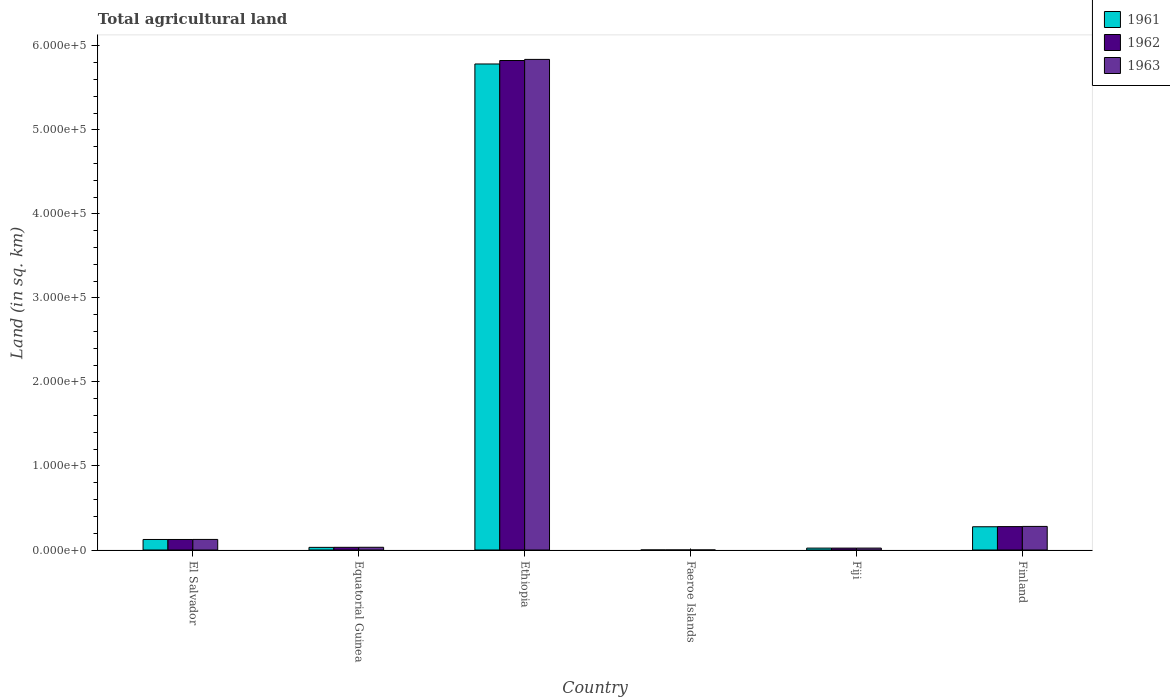How many different coloured bars are there?
Provide a succinct answer. 3. What is the label of the 5th group of bars from the left?
Give a very brief answer. Fiji. In how many cases, is the number of bars for a given country not equal to the number of legend labels?
Give a very brief answer. 0. What is the total agricultural land in 1962 in El Salvador?
Your answer should be compact. 1.25e+04. Across all countries, what is the maximum total agricultural land in 1962?
Your response must be concise. 5.82e+05. Across all countries, what is the minimum total agricultural land in 1961?
Your answer should be very brief. 30. In which country was the total agricultural land in 1963 maximum?
Keep it short and to the point. Ethiopia. In which country was the total agricultural land in 1962 minimum?
Offer a very short reply. Faeroe Islands. What is the total total agricultural land in 1962 in the graph?
Keep it short and to the point. 6.28e+05. What is the difference between the total agricultural land in 1962 in Faeroe Islands and that in Finland?
Your answer should be very brief. -2.78e+04. What is the difference between the total agricultural land in 1961 in Ethiopia and the total agricultural land in 1963 in Fiji?
Provide a succinct answer. 5.76e+05. What is the average total agricultural land in 1961 per country?
Ensure brevity in your answer.  1.04e+05. What is the difference between the total agricultural land of/in 1961 and total agricultural land of/in 1962 in Faeroe Islands?
Provide a succinct answer. 0. What is the ratio of the total agricultural land in 1963 in Faeroe Islands to that in Finland?
Your answer should be compact. 0. Is the total agricultural land in 1963 in Equatorial Guinea less than that in Fiji?
Offer a terse response. No. What is the difference between the highest and the second highest total agricultural land in 1962?
Your answer should be very brief. -5.70e+05. What is the difference between the highest and the lowest total agricultural land in 1963?
Your response must be concise. 5.84e+05. Is the sum of the total agricultural land in 1963 in Ethiopia and Fiji greater than the maximum total agricultural land in 1961 across all countries?
Make the answer very short. Yes. What does the 2nd bar from the left in Finland represents?
Give a very brief answer. 1962. What does the 2nd bar from the right in Finland represents?
Provide a succinct answer. 1962. How many countries are there in the graph?
Your answer should be very brief. 6. Does the graph contain grids?
Your answer should be very brief. No. Where does the legend appear in the graph?
Ensure brevity in your answer.  Top right. How are the legend labels stacked?
Make the answer very short. Vertical. What is the title of the graph?
Your answer should be very brief. Total agricultural land. Does "1972" appear as one of the legend labels in the graph?
Give a very brief answer. No. What is the label or title of the X-axis?
Offer a very short reply. Country. What is the label or title of the Y-axis?
Provide a succinct answer. Land (in sq. km). What is the Land (in sq. km) of 1961 in El Salvador?
Your answer should be very brief. 1.25e+04. What is the Land (in sq. km) of 1962 in El Salvador?
Ensure brevity in your answer.  1.25e+04. What is the Land (in sq. km) in 1963 in El Salvador?
Offer a very short reply. 1.26e+04. What is the Land (in sq. km) in 1961 in Equatorial Guinea?
Ensure brevity in your answer.  3140. What is the Land (in sq. km) in 1962 in Equatorial Guinea?
Your answer should be very brief. 3190. What is the Land (in sq. km) in 1963 in Equatorial Guinea?
Your answer should be very brief. 3240. What is the Land (in sq. km) of 1961 in Ethiopia?
Provide a succinct answer. 5.78e+05. What is the Land (in sq. km) in 1962 in Ethiopia?
Provide a succinct answer. 5.82e+05. What is the Land (in sq. km) in 1963 in Ethiopia?
Your answer should be very brief. 5.84e+05. What is the Land (in sq. km) in 1961 in Faeroe Islands?
Your answer should be compact. 30. What is the Land (in sq. km) of 1962 in Faeroe Islands?
Give a very brief answer. 30. What is the Land (in sq. km) in 1961 in Fiji?
Provide a succinct answer. 2270. What is the Land (in sq. km) in 1962 in Fiji?
Provide a short and direct response. 2270. What is the Land (in sq. km) of 1963 in Fiji?
Provide a short and direct response. 2280. What is the Land (in sq. km) in 1961 in Finland?
Give a very brief answer. 2.77e+04. What is the Land (in sq. km) of 1962 in Finland?
Your response must be concise. 2.79e+04. What is the Land (in sq. km) in 1963 in Finland?
Ensure brevity in your answer.  2.81e+04. Across all countries, what is the maximum Land (in sq. km) in 1961?
Provide a succinct answer. 5.78e+05. Across all countries, what is the maximum Land (in sq. km) in 1962?
Provide a succinct answer. 5.82e+05. Across all countries, what is the maximum Land (in sq. km) in 1963?
Provide a succinct answer. 5.84e+05. Across all countries, what is the minimum Land (in sq. km) in 1962?
Make the answer very short. 30. What is the total Land (in sq. km) in 1961 in the graph?
Ensure brevity in your answer.  6.24e+05. What is the total Land (in sq. km) of 1962 in the graph?
Provide a succinct answer. 6.28e+05. What is the total Land (in sq. km) in 1963 in the graph?
Your answer should be compact. 6.30e+05. What is the difference between the Land (in sq. km) of 1961 in El Salvador and that in Equatorial Guinea?
Provide a short and direct response. 9380. What is the difference between the Land (in sq. km) of 1962 in El Salvador and that in Equatorial Guinea?
Make the answer very short. 9330. What is the difference between the Land (in sq. km) in 1963 in El Salvador and that in Equatorial Guinea?
Provide a succinct answer. 9340. What is the difference between the Land (in sq. km) of 1961 in El Salvador and that in Ethiopia?
Your response must be concise. -5.66e+05. What is the difference between the Land (in sq. km) in 1962 in El Salvador and that in Ethiopia?
Ensure brevity in your answer.  -5.70e+05. What is the difference between the Land (in sq. km) of 1963 in El Salvador and that in Ethiopia?
Provide a short and direct response. -5.71e+05. What is the difference between the Land (in sq. km) in 1961 in El Salvador and that in Faeroe Islands?
Provide a short and direct response. 1.25e+04. What is the difference between the Land (in sq. km) of 1962 in El Salvador and that in Faeroe Islands?
Your answer should be very brief. 1.25e+04. What is the difference between the Land (in sq. km) in 1963 in El Salvador and that in Faeroe Islands?
Provide a succinct answer. 1.26e+04. What is the difference between the Land (in sq. km) of 1961 in El Salvador and that in Fiji?
Give a very brief answer. 1.02e+04. What is the difference between the Land (in sq. km) in 1962 in El Salvador and that in Fiji?
Offer a very short reply. 1.02e+04. What is the difference between the Land (in sq. km) of 1963 in El Salvador and that in Fiji?
Your answer should be very brief. 1.03e+04. What is the difference between the Land (in sq. km) in 1961 in El Salvador and that in Finland?
Ensure brevity in your answer.  -1.51e+04. What is the difference between the Land (in sq. km) in 1962 in El Salvador and that in Finland?
Offer a terse response. -1.53e+04. What is the difference between the Land (in sq. km) of 1963 in El Salvador and that in Finland?
Your answer should be very brief. -1.55e+04. What is the difference between the Land (in sq. km) in 1961 in Equatorial Guinea and that in Ethiopia?
Your response must be concise. -5.75e+05. What is the difference between the Land (in sq. km) of 1962 in Equatorial Guinea and that in Ethiopia?
Ensure brevity in your answer.  -5.79e+05. What is the difference between the Land (in sq. km) in 1963 in Equatorial Guinea and that in Ethiopia?
Offer a terse response. -5.81e+05. What is the difference between the Land (in sq. km) of 1961 in Equatorial Guinea and that in Faeroe Islands?
Keep it short and to the point. 3110. What is the difference between the Land (in sq. km) in 1962 in Equatorial Guinea and that in Faeroe Islands?
Provide a short and direct response. 3160. What is the difference between the Land (in sq. km) in 1963 in Equatorial Guinea and that in Faeroe Islands?
Give a very brief answer. 3210. What is the difference between the Land (in sq. km) in 1961 in Equatorial Guinea and that in Fiji?
Provide a short and direct response. 870. What is the difference between the Land (in sq. km) of 1962 in Equatorial Guinea and that in Fiji?
Provide a short and direct response. 920. What is the difference between the Land (in sq. km) of 1963 in Equatorial Guinea and that in Fiji?
Provide a short and direct response. 960. What is the difference between the Land (in sq. km) of 1961 in Equatorial Guinea and that in Finland?
Your answer should be very brief. -2.45e+04. What is the difference between the Land (in sq. km) of 1962 in Equatorial Guinea and that in Finland?
Your answer should be very brief. -2.47e+04. What is the difference between the Land (in sq. km) of 1963 in Equatorial Guinea and that in Finland?
Ensure brevity in your answer.  -2.48e+04. What is the difference between the Land (in sq. km) in 1961 in Ethiopia and that in Faeroe Islands?
Make the answer very short. 5.78e+05. What is the difference between the Land (in sq. km) of 1962 in Ethiopia and that in Faeroe Islands?
Your response must be concise. 5.82e+05. What is the difference between the Land (in sq. km) of 1963 in Ethiopia and that in Faeroe Islands?
Offer a very short reply. 5.84e+05. What is the difference between the Land (in sq. km) in 1961 in Ethiopia and that in Fiji?
Keep it short and to the point. 5.76e+05. What is the difference between the Land (in sq. km) of 1962 in Ethiopia and that in Fiji?
Give a very brief answer. 5.80e+05. What is the difference between the Land (in sq. km) of 1963 in Ethiopia and that in Fiji?
Offer a terse response. 5.82e+05. What is the difference between the Land (in sq. km) of 1961 in Ethiopia and that in Finland?
Your answer should be compact. 5.51e+05. What is the difference between the Land (in sq. km) of 1962 in Ethiopia and that in Finland?
Provide a short and direct response. 5.55e+05. What is the difference between the Land (in sq. km) of 1963 in Ethiopia and that in Finland?
Give a very brief answer. 5.56e+05. What is the difference between the Land (in sq. km) of 1961 in Faeroe Islands and that in Fiji?
Your response must be concise. -2240. What is the difference between the Land (in sq. km) in 1962 in Faeroe Islands and that in Fiji?
Provide a short and direct response. -2240. What is the difference between the Land (in sq. km) of 1963 in Faeroe Islands and that in Fiji?
Provide a short and direct response. -2250. What is the difference between the Land (in sq. km) in 1961 in Faeroe Islands and that in Finland?
Ensure brevity in your answer.  -2.76e+04. What is the difference between the Land (in sq. km) in 1962 in Faeroe Islands and that in Finland?
Your answer should be compact. -2.78e+04. What is the difference between the Land (in sq. km) of 1963 in Faeroe Islands and that in Finland?
Keep it short and to the point. -2.80e+04. What is the difference between the Land (in sq. km) of 1961 in Fiji and that in Finland?
Keep it short and to the point. -2.54e+04. What is the difference between the Land (in sq. km) of 1962 in Fiji and that in Finland?
Your answer should be compact. -2.56e+04. What is the difference between the Land (in sq. km) in 1963 in Fiji and that in Finland?
Your answer should be very brief. -2.58e+04. What is the difference between the Land (in sq. km) in 1961 in El Salvador and the Land (in sq. km) in 1962 in Equatorial Guinea?
Your answer should be compact. 9330. What is the difference between the Land (in sq. km) in 1961 in El Salvador and the Land (in sq. km) in 1963 in Equatorial Guinea?
Your answer should be compact. 9280. What is the difference between the Land (in sq. km) of 1962 in El Salvador and the Land (in sq. km) of 1963 in Equatorial Guinea?
Your answer should be very brief. 9280. What is the difference between the Land (in sq. km) in 1961 in El Salvador and the Land (in sq. km) in 1962 in Ethiopia?
Your answer should be compact. -5.70e+05. What is the difference between the Land (in sq. km) in 1961 in El Salvador and the Land (in sq. km) in 1963 in Ethiopia?
Make the answer very short. -5.71e+05. What is the difference between the Land (in sq. km) in 1962 in El Salvador and the Land (in sq. km) in 1963 in Ethiopia?
Keep it short and to the point. -5.71e+05. What is the difference between the Land (in sq. km) of 1961 in El Salvador and the Land (in sq. km) of 1962 in Faeroe Islands?
Provide a short and direct response. 1.25e+04. What is the difference between the Land (in sq. km) of 1961 in El Salvador and the Land (in sq. km) of 1963 in Faeroe Islands?
Your answer should be very brief. 1.25e+04. What is the difference between the Land (in sq. km) in 1962 in El Salvador and the Land (in sq. km) in 1963 in Faeroe Islands?
Provide a succinct answer. 1.25e+04. What is the difference between the Land (in sq. km) in 1961 in El Salvador and the Land (in sq. km) in 1962 in Fiji?
Make the answer very short. 1.02e+04. What is the difference between the Land (in sq. km) in 1961 in El Salvador and the Land (in sq. km) in 1963 in Fiji?
Your response must be concise. 1.02e+04. What is the difference between the Land (in sq. km) in 1962 in El Salvador and the Land (in sq. km) in 1963 in Fiji?
Give a very brief answer. 1.02e+04. What is the difference between the Land (in sq. km) of 1961 in El Salvador and the Land (in sq. km) of 1962 in Finland?
Provide a succinct answer. -1.53e+04. What is the difference between the Land (in sq. km) in 1961 in El Salvador and the Land (in sq. km) in 1963 in Finland?
Offer a very short reply. -1.55e+04. What is the difference between the Land (in sq. km) of 1962 in El Salvador and the Land (in sq. km) of 1963 in Finland?
Your answer should be very brief. -1.55e+04. What is the difference between the Land (in sq. km) of 1961 in Equatorial Guinea and the Land (in sq. km) of 1962 in Ethiopia?
Your response must be concise. -5.79e+05. What is the difference between the Land (in sq. km) of 1961 in Equatorial Guinea and the Land (in sq. km) of 1963 in Ethiopia?
Your answer should be compact. -5.81e+05. What is the difference between the Land (in sq. km) in 1962 in Equatorial Guinea and the Land (in sq. km) in 1963 in Ethiopia?
Provide a short and direct response. -5.81e+05. What is the difference between the Land (in sq. km) of 1961 in Equatorial Guinea and the Land (in sq. km) of 1962 in Faeroe Islands?
Your answer should be very brief. 3110. What is the difference between the Land (in sq. km) in 1961 in Equatorial Guinea and the Land (in sq. km) in 1963 in Faeroe Islands?
Ensure brevity in your answer.  3110. What is the difference between the Land (in sq. km) in 1962 in Equatorial Guinea and the Land (in sq. km) in 1963 in Faeroe Islands?
Offer a very short reply. 3160. What is the difference between the Land (in sq. km) in 1961 in Equatorial Guinea and the Land (in sq. km) in 1962 in Fiji?
Your answer should be very brief. 870. What is the difference between the Land (in sq. km) in 1961 in Equatorial Guinea and the Land (in sq. km) in 1963 in Fiji?
Give a very brief answer. 860. What is the difference between the Land (in sq. km) in 1962 in Equatorial Guinea and the Land (in sq. km) in 1963 in Fiji?
Your response must be concise. 910. What is the difference between the Land (in sq. km) in 1961 in Equatorial Guinea and the Land (in sq. km) in 1962 in Finland?
Offer a terse response. -2.47e+04. What is the difference between the Land (in sq. km) in 1961 in Equatorial Guinea and the Land (in sq. km) in 1963 in Finland?
Keep it short and to the point. -2.49e+04. What is the difference between the Land (in sq. km) of 1962 in Equatorial Guinea and the Land (in sq. km) of 1963 in Finland?
Provide a succinct answer. -2.49e+04. What is the difference between the Land (in sq. km) of 1961 in Ethiopia and the Land (in sq. km) of 1962 in Faeroe Islands?
Make the answer very short. 5.78e+05. What is the difference between the Land (in sq. km) of 1961 in Ethiopia and the Land (in sq. km) of 1963 in Faeroe Islands?
Provide a succinct answer. 5.78e+05. What is the difference between the Land (in sq. km) in 1962 in Ethiopia and the Land (in sq. km) in 1963 in Faeroe Islands?
Make the answer very short. 5.82e+05. What is the difference between the Land (in sq. km) in 1961 in Ethiopia and the Land (in sq. km) in 1962 in Fiji?
Your answer should be compact. 5.76e+05. What is the difference between the Land (in sq. km) in 1961 in Ethiopia and the Land (in sq. km) in 1963 in Fiji?
Give a very brief answer. 5.76e+05. What is the difference between the Land (in sq. km) of 1962 in Ethiopia and the Land (in sq. km) of 1963 in Fiji?
Your answer should be compact. 5.80e+05. What is the difference between the Land (in sq. km) in 1961 in Ethiopia and the Land (in sq. km) in 1962 in Finland?
Your response must be concise. 5.51e+05. What is the difference between the Land (in sq. km) of 1961 in Ethiopia and the Land (in sq. km) of 1963 in Finland?
Make the answer very short. 5.50e+05. What is the difference between the Land (in sq. km) in 1962 in Ethiopia and the Land (in sq. km) in 1963 in Finland?
Give a very brief answer. 5.54e+05. What is the difference between the Land (in sq. km) of 1961 in Faeroe Islands and the Land (in sq. km) of 1962 in Fiji?
Offer a terse response. -2240. What is the difference between the Land (in sq. km) of 1961 in Faeroe Islands and the Land (in sq. km) of 1963 in Fiji?
Give a very brief answer. -2250. What is the difference between the Land (in sq. km) in 1962 in Faeroe Islands and the Land (in sq. km) in 1963 in Fiji?
Provide a succinct answer. -2250. What is the difference between the Land (in sq. km) in 1961 in Faeroe Islands and the Land (in sq. km) in 1962 in Finland?
Provide a short and direct response. -2.78e+04. What is the difference between the Land (in sq. km) in 1961 in Faeroe Islands and the Land (in sq. km) in 1963 in Finland?
Offer a very short reply. -2.80e+04. What is the difference between the Land (in sq. km) of 1962 in Faeroe Islands and the Land (in sq. km) of 1963 in Finland?
Ensure brevity in your answer.  -2.80e+04. What is the difference between the Land (in sq. km) of 1961 in Fiji and the Land (in sq. km) of 1962 in Finland?
Offer a very short reply. -2.56e+04. What is the difference between the Land (in sq. km) of 1961 in Fiji and the Land (in sq. km) of 1963 in Finland?
Keep it short and to the point. -2.58e+04. What is the difference between the Land (in sq. km) of 1962 in Fiji and the Land (in sq. km) of 1963 in Finland?
Give a very brief answer. -2.58e+04. What is the average Land (in sq. km) of 1961 per country?
Keep it short and to the point. 1.04e+05. What is the average Land (in sq. km) in 1962 per country?
Make the answer very short. 1.05e+05. What is the average Land (in sq. km) in 1963 per country?
Keep it short and to the point. 1.05e+05. What is the difference between the Land (in sq. km) of 1961 and Land (in sq. km) of 1962 in El Salvador?
Offer a very short reply. 0. What is the difference between the Land (in sq. km) of 1961 and Land (in sq. km) of 1963 in El Salvador?
Keep it short and to the point. -60. What is the difference between the Land (in sq. km) of 1962 and Land (in sq. km) of 1963 in El Salvador?
Offer a terse response. -60. What is the difference between the Land (in sq. km) in 1961 and Land (in sq. km) in 1962 in Equatorial Guinea?
Give a very brief answer. -50. What is the difference between the Land (in sq. km) of 1961 and Land (in sq. km) of 1963 in Equatorial Guinea?
Provide a short and direct response. -100. What is the difference between the Land (in sq. km) in 1961 and Land (in sq. km) in 1962 in Ethiopia?
Provide a succinct answer. -4130. What is the difference between the Land (in sq. km) in 1961 and Land (in sq. km) in 1963 in Ethiopia?
Offer a terse response. -5440. What is the difference between the Land (in sq. km) of 1962 and Land (in sq. km) of 1963 in Ethiopia?
Give a very brief answer. -1310. What is the difference between the Land (in sq. km) in 1961 and Land (in sq. km) in 1963 in Faeroe Islands?
Give a very brief answer. 0. What is the difference between the Land (in sq. km) of 1962 and Land (in sq. km) of 1963 in Fiji?
Your response must be concise. -10. What is the difference between the Land (in sq. km) of 1961 and Land (in sq. km) of 1962 in Finland?
Offer a terse response. -194. What is the difference between the Land (in sq. km) of 1961 and Land (in sq. km) of 1963 in Finland?
Your answer should be compact. -408. What is the difference between the Land (in sq. km) in 1962 and Land (in sq. km) in 1963 in Finland?
Your response must be concise. -214. What is the ratio of the Land (in sq. km) in 1961 in El Salvador to that in Equatorial Guinea?
Offer a terse response. 3.99. What is the ratio of the Land (in sq. km) in 1962 in El Salvador to that in Equatorial Guinea?
Keep it short and to the point. 3.92. What is the ratio of the Land (in sq. km) of 1963 in El Salvador to that in Equatorial Guinea?
Give a very brief answer. 3.88. What is the ratio of the Land (in sq. km) of 1961 in El Salvador to that in Ethiopia?
Offer a terse response. 0.02. What is the ratio of the Land (in sq. km) in 1962 in El Salvador to that in Ethiopia?
Your answer should be compact. 0.02. What is the ratio of the Land (in sq. km) of 1963 in El Salvador to that in Ethiopia?
Give a very brief answer. 0.02. What is the ratio of the Land (in sq. km) of 1961 in El Salvador to that in Faeroe Islands?
Ensure brevity in your answer.  417.33. What is the ratio of the Land (in sq. km) of 1962 in El Salvador to that in Faeroe Islands?
Provide a short and direct response. 417.33. What is the ratio of the Land (in sq. km) in 1963 in El Salvador to that in Faeroe Islands?
Keep it short and to the point. 419.33. What is the ratio of the Land (in sq. km) of 1961 in El Salvador to that in Fiji?
Your response must be concise. 5.52. What is the ratio of the Land (in sq. km) in 1962 in El Salvador to that in Fiji?
Offer a very short reply. 5.52. What is the ratio of the Land (in sq. km) of 1963 in El Salvador to that in Fiji?
Make the answer very short. 5.52. What is the ratio of the Land (in sq. km) of 1961 in El Salvador to that in Finland?
Offer a terse response. 0.45. What is the ratio of the Land (in sq. km) of 1962 in El Salvador to that in Finland?
Keep it short and to the point. 0.45. What is the ratio of the Land (in sq. km) of 1963 in El Salvador to that in Finland?
Your answer should be very brief. 0.45. What is the ratio of the Land (in sq. km) of 1961 in Equatorial Guinea to that in Ethiopia?
Offer a terse response. 0.01. What is the ratio of the Land (in sq. km) of 1962 in Equatorial Guinea to that in Ethiopia?
Your response must be concise. 0.01. What is the ratio of the Land (in sq. km) in 1963 in Equatorial Guinea to that in Ethiopia?
Provide a short and direct response. 0.01. What is the ratio of the Land (in sq. km) of 1961 in Equatorial Guinea to that in Faeroe Islands?
Provide a succinct answer. 104.67. What is the ratio of the Land (in sq. km) in 1962 in Equatorial Guinea to that in Faeroe Islands?
Provide a short and direct response. 106.33. What is the ratio of the Land (in sq. km) in 1963 in Equatorial Guinea to that in Faeroe Islands?
Your response must be concise. 108. What is the ratio of the Land (in sq. km) of 1961 in Equatorial Guinea to that in Fiji?
Offer a terse response. 1.38. What is the ratio of the Land (in sq. km) in 1962 in Equatorial Guinea to that in Fiji?
Provide a short and direct response. 1.41. What is the ratio of the Land (in sq. km) in 1963 in Equatorial Guinea to that in Fiji?
Make the answer very short. 1.42. What is the ratio of the Land (in sq. km) of 1961 in Equatorial Guinea to that in Finland?
Offer a terse response. 0.11. What is the ratio of the Land (in sq. km) in 1962 in Equatorial Guinea to that in Finland?
Offer a very short reply. 0.11. What is the ratio of the Land (in sq. km) in 1963 in Equatorial Guinea to that in Finland?
Give a very brief answer. 0.12. What is the ratio of the Land (in sq. km) of 1961 in Ethiopia to that in Faeroe Islands?
Offer a terse response. 1.93e+04. What is the ratio of the Land (in sq. km) of 1962 in Ethiopia to that in Faeroe Islands?
Provide a short and direct response. 1.94e+04. What is the ratio of the Land (in sq. km) in 1963 in Ethiopia to that in Faeroe Islands?
Your answer should be very brief. 1.95e+04. What is the ratio of the Land (in sq. km) of 1961 in Ethiopia to that in Fiji?
Ensure brevity in your answer.  254.78. What is the ratio of the Land (in sq. km) of 1962 in Ethiopia to that in Fiji?
Offer a terse response. 256.6. What is the ratio of the Land (in sq. km) of 1963 in Ethiopia to that in Fiji?
Provide a succinct answer. 256.05. What is the ratio of the Land (in sq. km) in 1961 in Ethiopia to that in Finland?
Keep it short and to the point. 20.91. What is the ratio of the Land (in sq. km) of 1962 in Ethiopia to that in Finland?
Provide a succinct answer. 20.91. What is the ratio of the Land (in sq. km) of 1963 in Ethiopia to that in Finland?
Your answer should be very brief. 20.8. What is the ratio of the Land (in sq. km) of 1961 in Faeroe Islands to that in Fiji?
Keep it short and to the point. 0.01. What is the ratio of the Land (in sq. km) of 1962 in Faeroe Islands to that in Fiji?
Keep it short and to the point. 0.01. What is the ratio of the Land (in sq. km) in 1963 in Faeroe Islands to that in Fiji?
Provide a succinct answer. 0.01. What is the ratio of the Land (in sq. km) of 1961 in Faeroe Islands to that in Finland?
Ensure brevity in your answer.  0. What is the ratio of the Land (in sq. km) of 1962 in Faeroe Islands to that in Finland?
Provide a succinct answer. 0. What is the ratio of the Land (in sq. km) of 1963 in Faeroe Islands to that in Finland?
Give a very brief answer. 0. What is the ratio of the Land (in sq. km) in 1961 in Fiji to that in Finland?
Provide a succinct answer. 0.08. What is the ratio of the Land (in sq. km) in 1962 in Fiji to that in Finland?
Your response must be concise. 0.08. What is the ratio of the Land (in sq. km) in 1963 in Fiji to that in Finland?
Ensure brevity in your answer.  0.08. What is the difference between the highest and the second highest Land (in sq. km) in 1961?
Ensure brevity in your answer.  5.51e+05. What is the difference between the highest and the second highest Land (in sq. km) of 1962?
Provide a succinct answer. 5.55e+05. What is the difference between the highest and the second highest Land (in sq. km) of 1963?
Offer a terse response. 5.56e+05. What is the difference between the highest and the lowest Land (in sq. km) in 1961?
Keep it short and to the point. 5.78e+05. What is the difference between the highest and the lowest Land (in sq. km) of 1962?
Your answer should be compact. 5.82e+05. What is the difference between the highest and the lowest Land (in sq. km) of 1963?
Your response must be concise. 5.84e+05. 